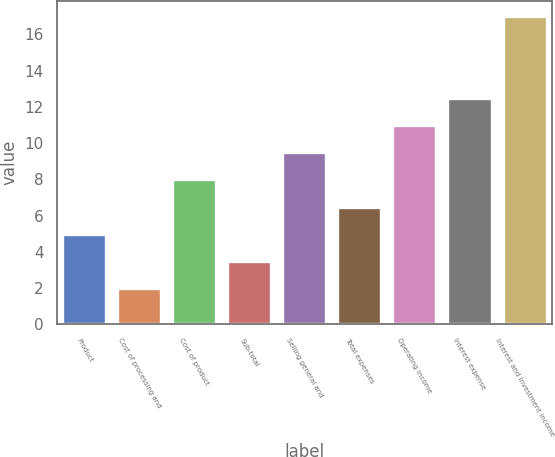<chart> <loc_0><loc_0><loc_500><loc_500><bar_chart><fcel>Product<fcel>Cost of processing and<fcel>Cost of product<fcel>Sub-total<fcel>Selling general and<fcel>Total expenses<fcel>Operating income<fcel>Interest expense<fcel>Interest and investment income<nl><fcel>5<fcel>2<fcel>8<fcel>3.5<fcel>9.5<fcel>6.5<fcel>11<fcel>12.5<fcel>17<nl></chart> 